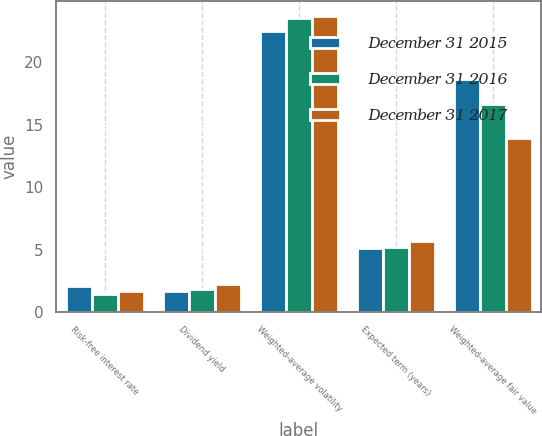<chart> <loc_0><loc_0><loc_500><loc_500><stacked_bar_chart><ecel><fcel>Risk-free interest rate<fcel>Dividend yield<fcel>Weighted-average volatility<fcel>Expected term (years)<fcel>Weighted-average fair value<nl><fcel>December 31 2015<fcel>2.04<fcel>1.64<fcel>22.52<fcel>5.1<fcel>18.66<nl><fcel>December 31 2016<fcel>1.4<fcel>1.81<fcel>23.53<fcel>5.2<fcel>16.65<nl><fcel>December 31 2017<fcel>1.7<fcel>2.2<fcel>23.71<fcel>5.7<fcel>13.98<nl></chart> 